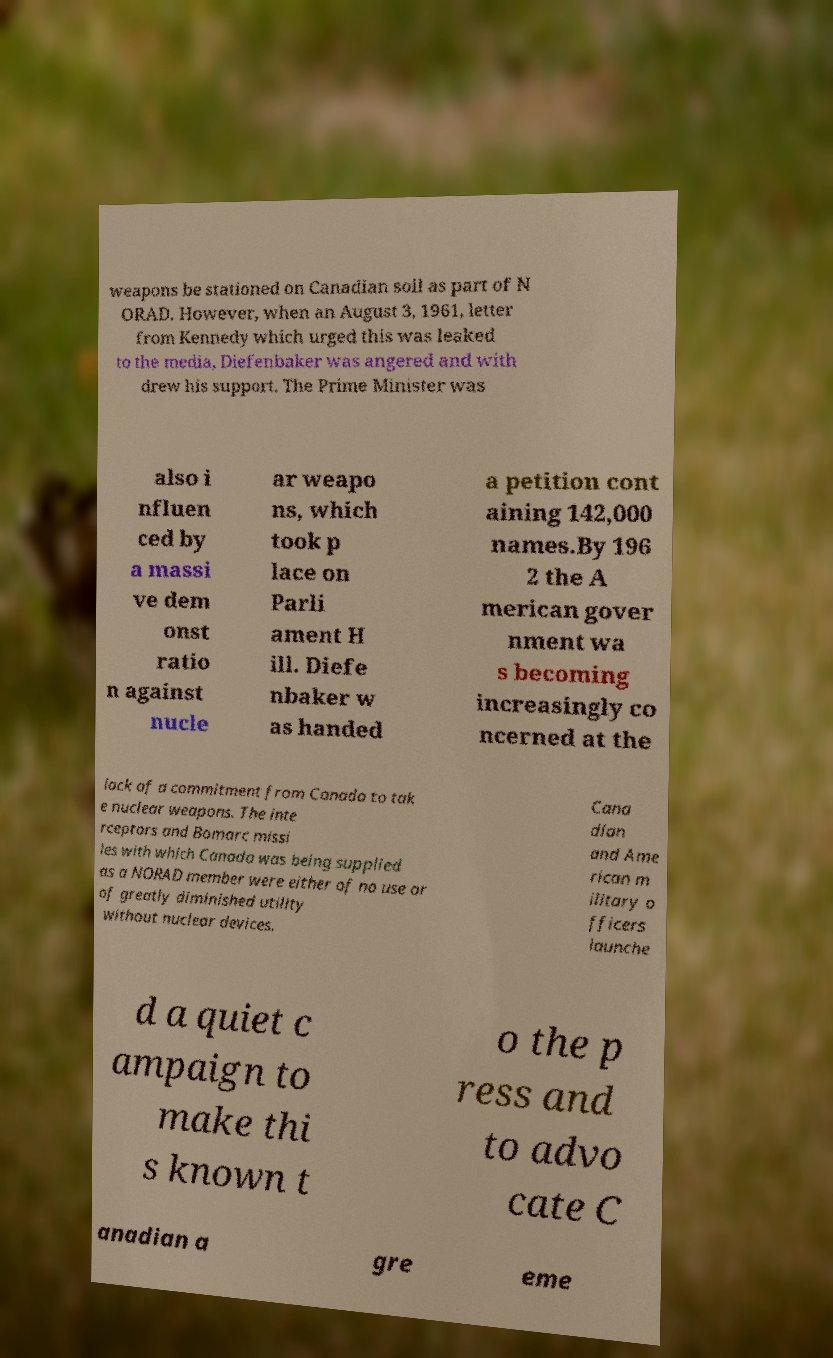I need the written content from this picture converted into text. Can you do that? weapons be stationed on Canadian soil as part of N ORAD. However, when an August 3, 1961, letter from Kennedy which urged this was leaked to the media, Diefenbaker was angered and with drew his support. The Prime Minister was also i nfluen ced by a massi ve dem onst ratio n against nucle ar weapo ns, which took p lace on Parli ament H ill. Diefe nbaker w as handed a petition cont aining 142,000 names.By 196 2 the A merican gover nment wa s becoming increasingly co ncerned at the lack of a commitment from Canada to tak e nuclear weapons. The inte rceptors and Bomarc missi les with which Canada was being supplied as a NORAD member were either of no use or of greatly diminished utility without nuclear devices. Cana dian and Ame rican m ilitary o fficers launche d a quiet c ampaign to make thi s known t o the p ress and to advo cate C anadian a gre eme 